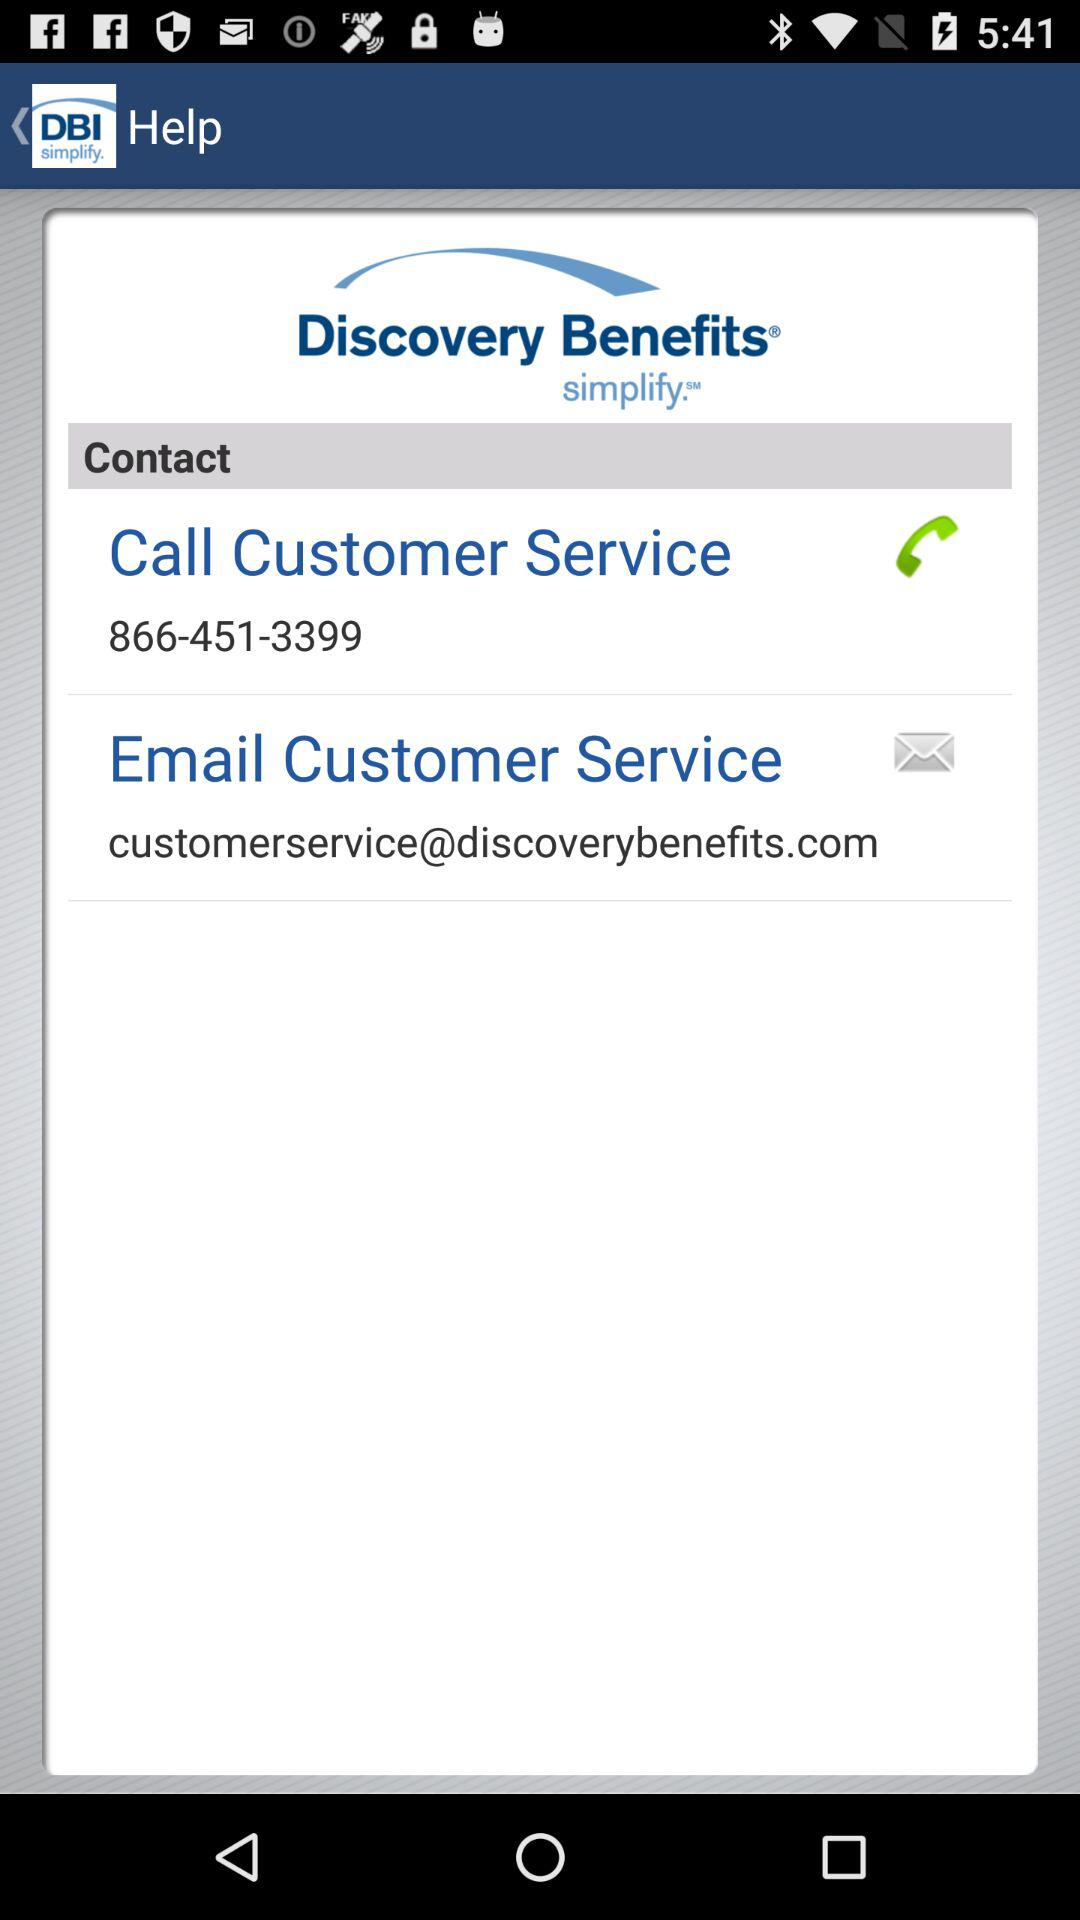How do you fax the customer service?
When the provided information is insufficient, respond with <no answer>. <no answer> 